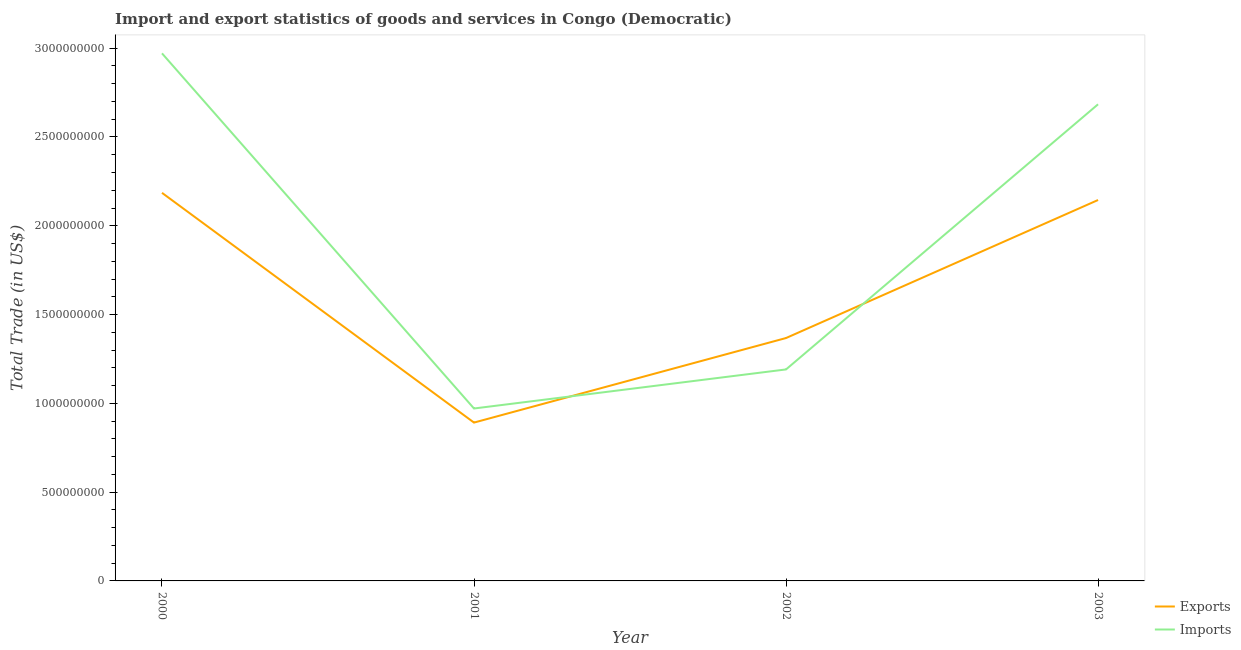How many different coloured lines are there?
Offer a very short reply. 2. Does the line corresponding to export of goods and services intersect with the line corresponding to imports of goods and services?
Your answer should be compact. Yes. What is the imports of goods and services in 2003?
Offer a very short reply. 2.68e+09. Across all years, what is the maximum export of goods and services?
Keep it short and to the point. 2.19e+09. Across all years, what is the minimum imports of goods and services?
Offer a terse response. 9.71e+08. In which year was the export of goods and services maximum?
Provide a succinct answer. 2000. What is the total export of goods and services in the graph?
Keep it short and to the point. 6.59e+09. What is the difference between the imports of goods and services in 2000 and that in 2003?
Your answer should be very brief. 2.87e+08. What is the difference between the imports of goods and services in 2003 and the export of goods and services in 2002?
Provide a short and direct response. 1.32e+09. What is the average imports of goods and services per year?
Ensure brevity in your answer.  1.95e+09. In the year 2001, what is the difference between the imports of goods and services and export of goods and services?
Provide a short and direct response. 7.93e+07. In how many years, is the export of goods and services greater than 2700000000 US$?
Your answer should be very brief. 0. What is the ratio of the imports of goods and services in 2002 to that in 2003?
Your answer should be very brief. 0.44. What is the difference between the highest and the second highest export of goods and services?
Offer a terse response. 4.05e+07. What is the difference between the highest and the lowest imports of goods and services?
Offer a terse response. 2.00e+09. In how many years, is the imports of goods and services greater than the average imports of goods and services taken over all years?
Give a very brief answer. 2. Is the imports of goods and services strictly less than the export of goods and services over the years?
Give a very brief answer. No. How many lines are there?
Offer a terse response. 2. How many years are there in the graph?
Provide a succinct answer. 4. Are the values on the major ticks of Y-axis written in scientific E-notation?
Keep it short and to the point. No. Does the graph contain grids?
Your response must be concise. No. How many legend labels are there?
Your answer should be very brief. 2. What is the title of the graph?
Offer a very short reply. Import and export statistics of goods and services in Congo (Democratic). Does "Under-5(male)" appear as one of the legend labels in the graph?
Make the answer very short. No. What is the label or title of the X-axis?
Ensure brevity in your answer.  Year. What is the label or title of the Y-axis?
Provide a succinct answer. Total Trade (in US$). What is the Total Trade (in US$) in Exports in 2000?
Offer a very short reply. 2.19e+09. What is the Total Trade (in US$) in Imports in 2000?
Your answer should be compact. 2.97e+09. What is the Total Trade (in US$) in Exports in 2001?
Make the answer very short. 8.92e+08. What is the Total Trade (in US$) of Imports in 2001?
Your answer should be compact. 9.71e+08. What is the Total Trade (in US$) in Exports in 2002?
Make the answer very short. 1.37e+09. What is the Total Trade (in US$) in Imports in 2002?
Provide a succinct answer. 1.19e+09. What is the Total Trade (in US$) of Exports in 2003?
Provide a succinct answer. 2.15e+09. What is the Total Trade (in US$) in Imports in 2003?
Keep it short and to the point. 2.68e+09. Across all years, what is the maximum Total Trade (in US$) in Exports?
Your answer should be very brief. 2.19e+09. Across all years, what is the maximum Total Trade (in US$) of Imports?
Your answer should be very brief. 2.97e+09. Across all years, what is the minimum Total Trade (in US$) in Exports?
Provide a short and direct response. 8.92e+08. Across all years, what is the minimum Total Trade (in US$) of Imports?
Offer a terse response. 9.71e+08. What is the total Total Trade (in US$) in Exports in the graph?
Your answer should be compact. 6.59e+09. What is the total Total Trade (in US$) of Imports in the graph?
Give a very brief answer. 7.82e+09. What is the difference between the Total Trade (in US$) of Exports in 2000 and that in 2001?
Your answer should be compact. 1.29e+09. What is the difference between the Total Trade (in US$) of Imports in 2000 and that in 2001?
Provide a succinct answer. 2.00e+09. What is the difference between the Total Trade (in US$) of Exports in 2000 and that in 2002?
Ensure brevity in your answer.  8.18e+08. What is the difference between the Total Trade (in US$) of Imports in 2000 and that in 2002?
Offer a terse response. 1.78e+09. What is the difference between the Total Trade (in US$) in Exports in 2000 and that in 2003?
Make the answer very short. 4.05e+07. What is the difference between the Total Trade (in US$) in Imports in 2000 and that in 2003?
Keep it short and to the point. 2.87e+08. What is the difference between the Total Trade (in US$) in Exports in 2001 and that in 2002?
Offer a terse response. -4.76e+08. What is the difference between the Total Trade (in US$) in Imports in 2001 and that in 2002?
Give a very brief answer. -2.20e+08. What is the difference between the Total Trade (in US$) of Exports in 2001 and that in 2003?
Provide a short and direct response. -1.25e+09. What is the difference between the Total Trade (in US$) in Imports in 2001 and that in 2003?
Offer a very short reply. -1.71e+09. What is the difference between the Total Trade (in US$) in Exports in 2002 and that in 2003?
Give a very brief answer. -7.77e+08. What is the difference between the Total Trade (in US$) in Imports in 2002 and that in 2003?
Give a very brief answer. -1.49e+09. What is the difference between the Total Trade (in US$) of Exports in 2000 and the Total Trade (in US$) of Imports in 2001?
Offer a terse response. 1.21e+09. What is the difference between the Total Trade (in US$) of Exports in 2000 and the Total Trade (in US$) of Imports in 2002?
Ensure brevity in your answer.  9.95e+08. What is the difference between the Total Trade (in US$) in Exports in 2000 and the Total Trade (in US$) in Imports in 2003?
Offer a terse response. -4.99e+08. What is the difference between the Total Trade (in US$) in Exports in 2001 and the Total Trade (in US$) in Imports in 2002?
Your response must be concise. -2.99e+08. What is the difference between the Total Trade (in US$) of Exports in 2001 and the Total Trade (in US$) of Imports in 2003?
Provide a short and direct response. -1.79e+09. What is the difference between the Total Trade (in US$) of Exports in 2002 and the Total Trade (in US$) of Imports in 2003?
Make the answer very short. -1.32e+09. What is the average Total Trade (in US$) of Exports per year?
Offer a terse response. 1.65e+09. What is the average Total Trade (in US$) in Imports per year?
Ensure brevity in your answer.  1.95e+09. In the year 2000, what is the difference between the Total Trade (in US$) of Exports and Total Trade (in US$) of Imports?
Your response must be concise. -7.86e+08. In the year 2001, what is the difference between the Total Trade (in US$) in Exports and Total Trade (in US$) in Imports?
Your answer should be compact. -7.93e+07. In the year 2002, what is the difference between the Total Trade (in US$) of Exports and Total Trade (in US$) of Imports?
Keep it short and to the point. 1.77e+08. In the year 2003, what is the difference between the Total Trade (in US$) of Exports and Total Trade (in US$) of Imports?
Your response must be concise. -5.39e+08. What is the ratio of the Total Trade (in US$) in Exports in 2000 to that in 2001?
Offer a very short reply. 2.45. What is the ratio of the Total Trade (in US$) in Imports in 2000 to that in 2001?
Provide a short and direct response. 3.06. What is the ratio of the Total Trade (in US$) in Exports in 2000 to that in 2002?
Provide a succinct answer. 1.6. What is the ratio of the Total Trade (in US$) in Imports in 2000 to that in 2002?
Your answer should be very brief. 2.49. What is the ratio of the Total Trade (in US$) in Exports in 2000 to that in 2003?
Make the answer very short. 1.02. What is the ratio of the Total Trade (in US$) in Imports in 2000 to that in 2003?
Your answer should be very brief. 1.11. What is the ratio of the Total Trade (in US$) of Exports in 2001 to that in 2002?
Your answer should be very brief. 0.65. What is the ratio of the Total Trade (in US$) in Imports in 2001 to that in 2002?
Your response must be concise. 0.82. What is the ratio of the Total Trade (in US$) in Exports in 2001 to that in 2003?
Ensure brevity in your answer.  0.42. What is the ratio of the Total Trade (in US$) of Imports in 2001 to that in 2003?
Your response must be concise. 0.36. What is the ratio of the Total Trade (in US$) in Exports in 2002 to that in 2003?
Your response must be concise. 0.64. What is the ratio of the Total Trade (in US$) of Imports in 2002 to that in 2003?
Your response must be concise. 0.44. What is the difference between the highest and the second highest Total Trade (in US$) of Exports?
Offer a very short reply. 4.05e+07. What is the difference between the highest and the second highest Total Trade (in US$) in Imports?
Provide a succinct answer. 2.87e+08. What is the difference between the highest and the lowest Total Trade (in US$) of Exports?
Provide a succinct answer. 1.29e+09. What is the difference between the highest and the lowest Total Trade (in US$) of Imports?
Make the answer very short. 2.00e+09. 